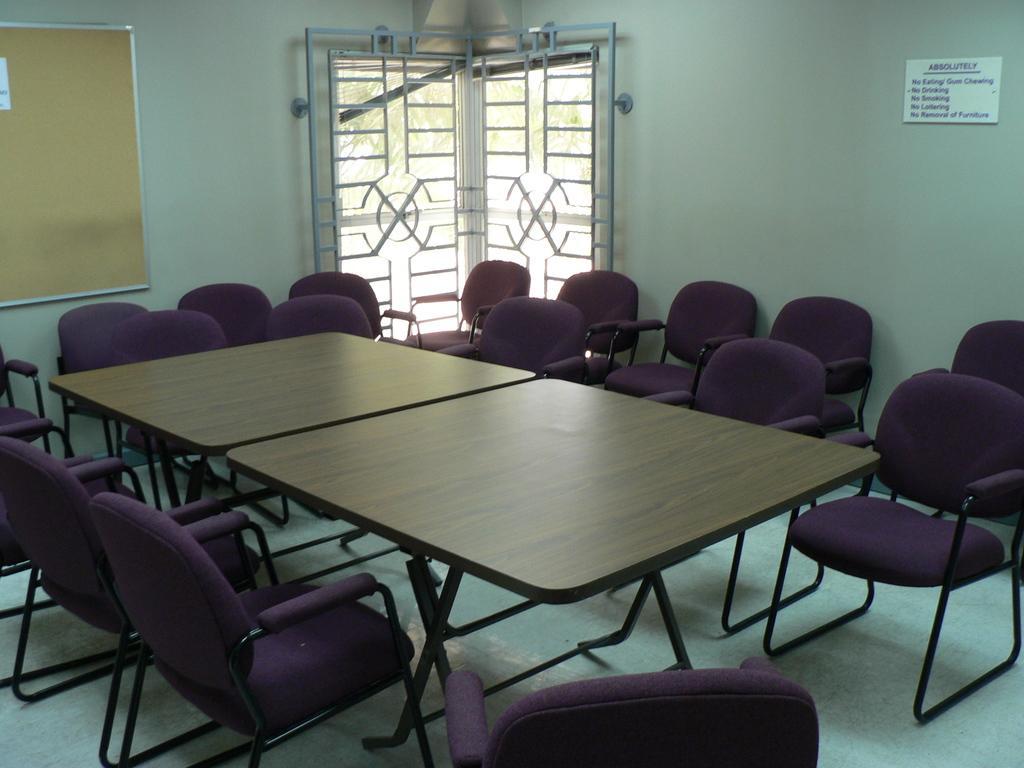Please provide a concise description of this image. In this image I can see the tables. To the side of the tables I can see the chairs which are in purple color. In the background I can see the boards and the window to the wall. I can also see some trees through the window. 